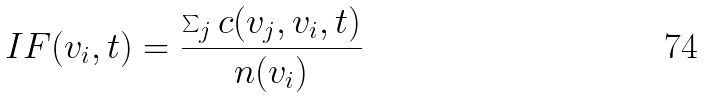Convert formula to latex. <formula><loc_0><loc_0><loc_500><loc_500>I F ( v _ { i } , t ) = \frac { \sum _ { j } c ( v _ { j } , v _ { i } , t ) } { n ( v _ { i } ) }</formula> 